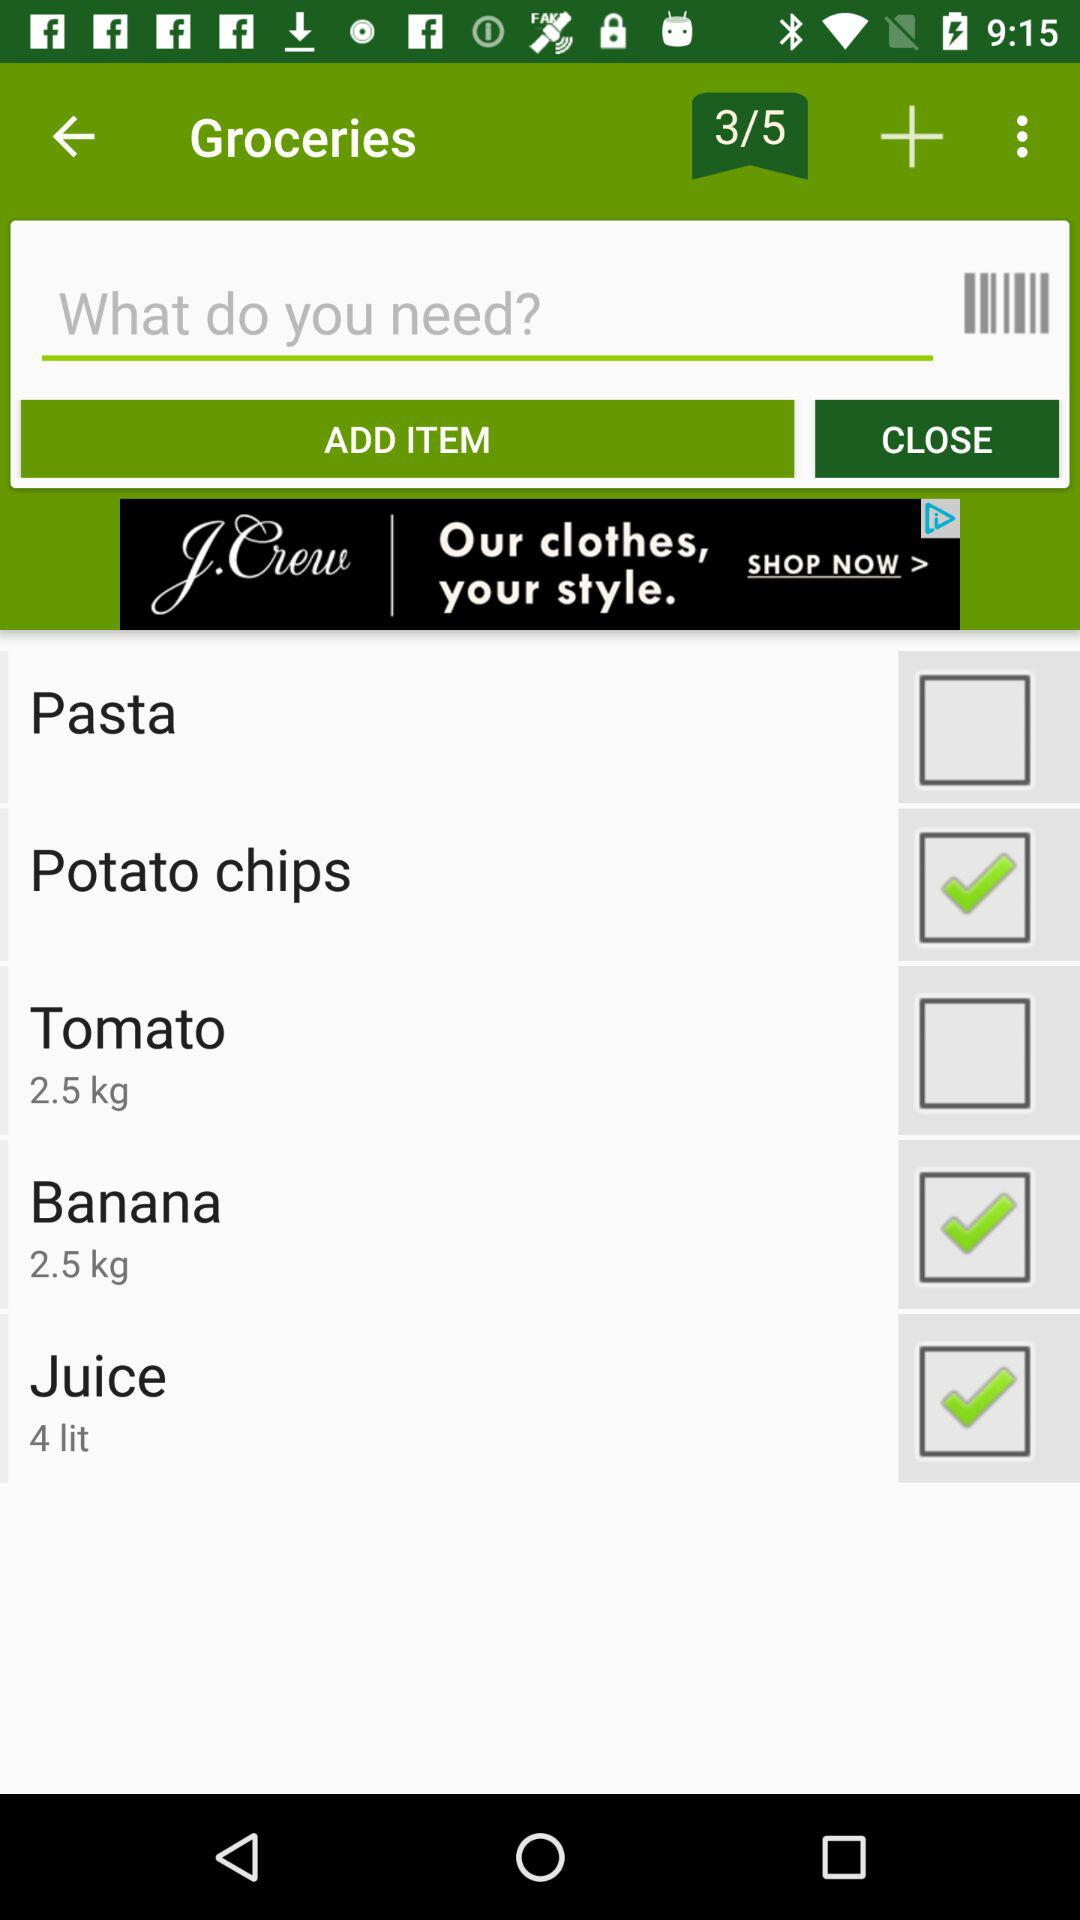How many kilos of bananas are selected? The selected kilos of bananas are 2.5. 